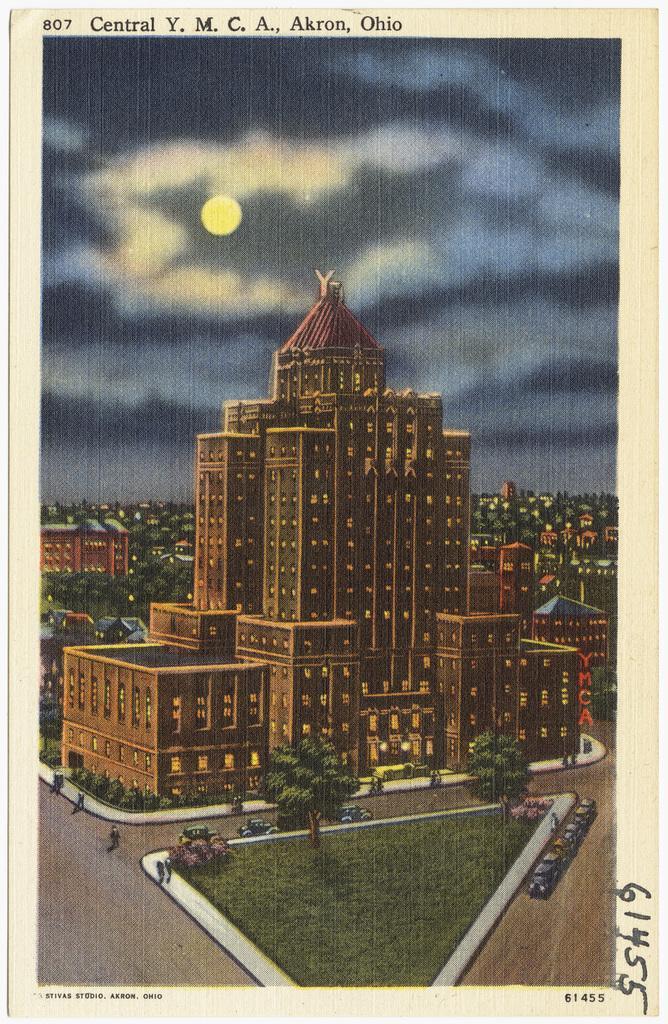Can you describe this image briefly? In the picture I can see the buildings and trees. I can see the vehicles and a few persons on the road. I can see the moon and clouds in the sky. 